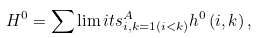Convert formula to latex. <formula><loc_0><loc_0><loc_500><loc_500>H ^ { 0 } = \sum \lim i t s _ { i , k = 1 \left ( i < k \right ) } ^ { A } h ^ { 0 } \left ( i , k \right ) ,</formula> 